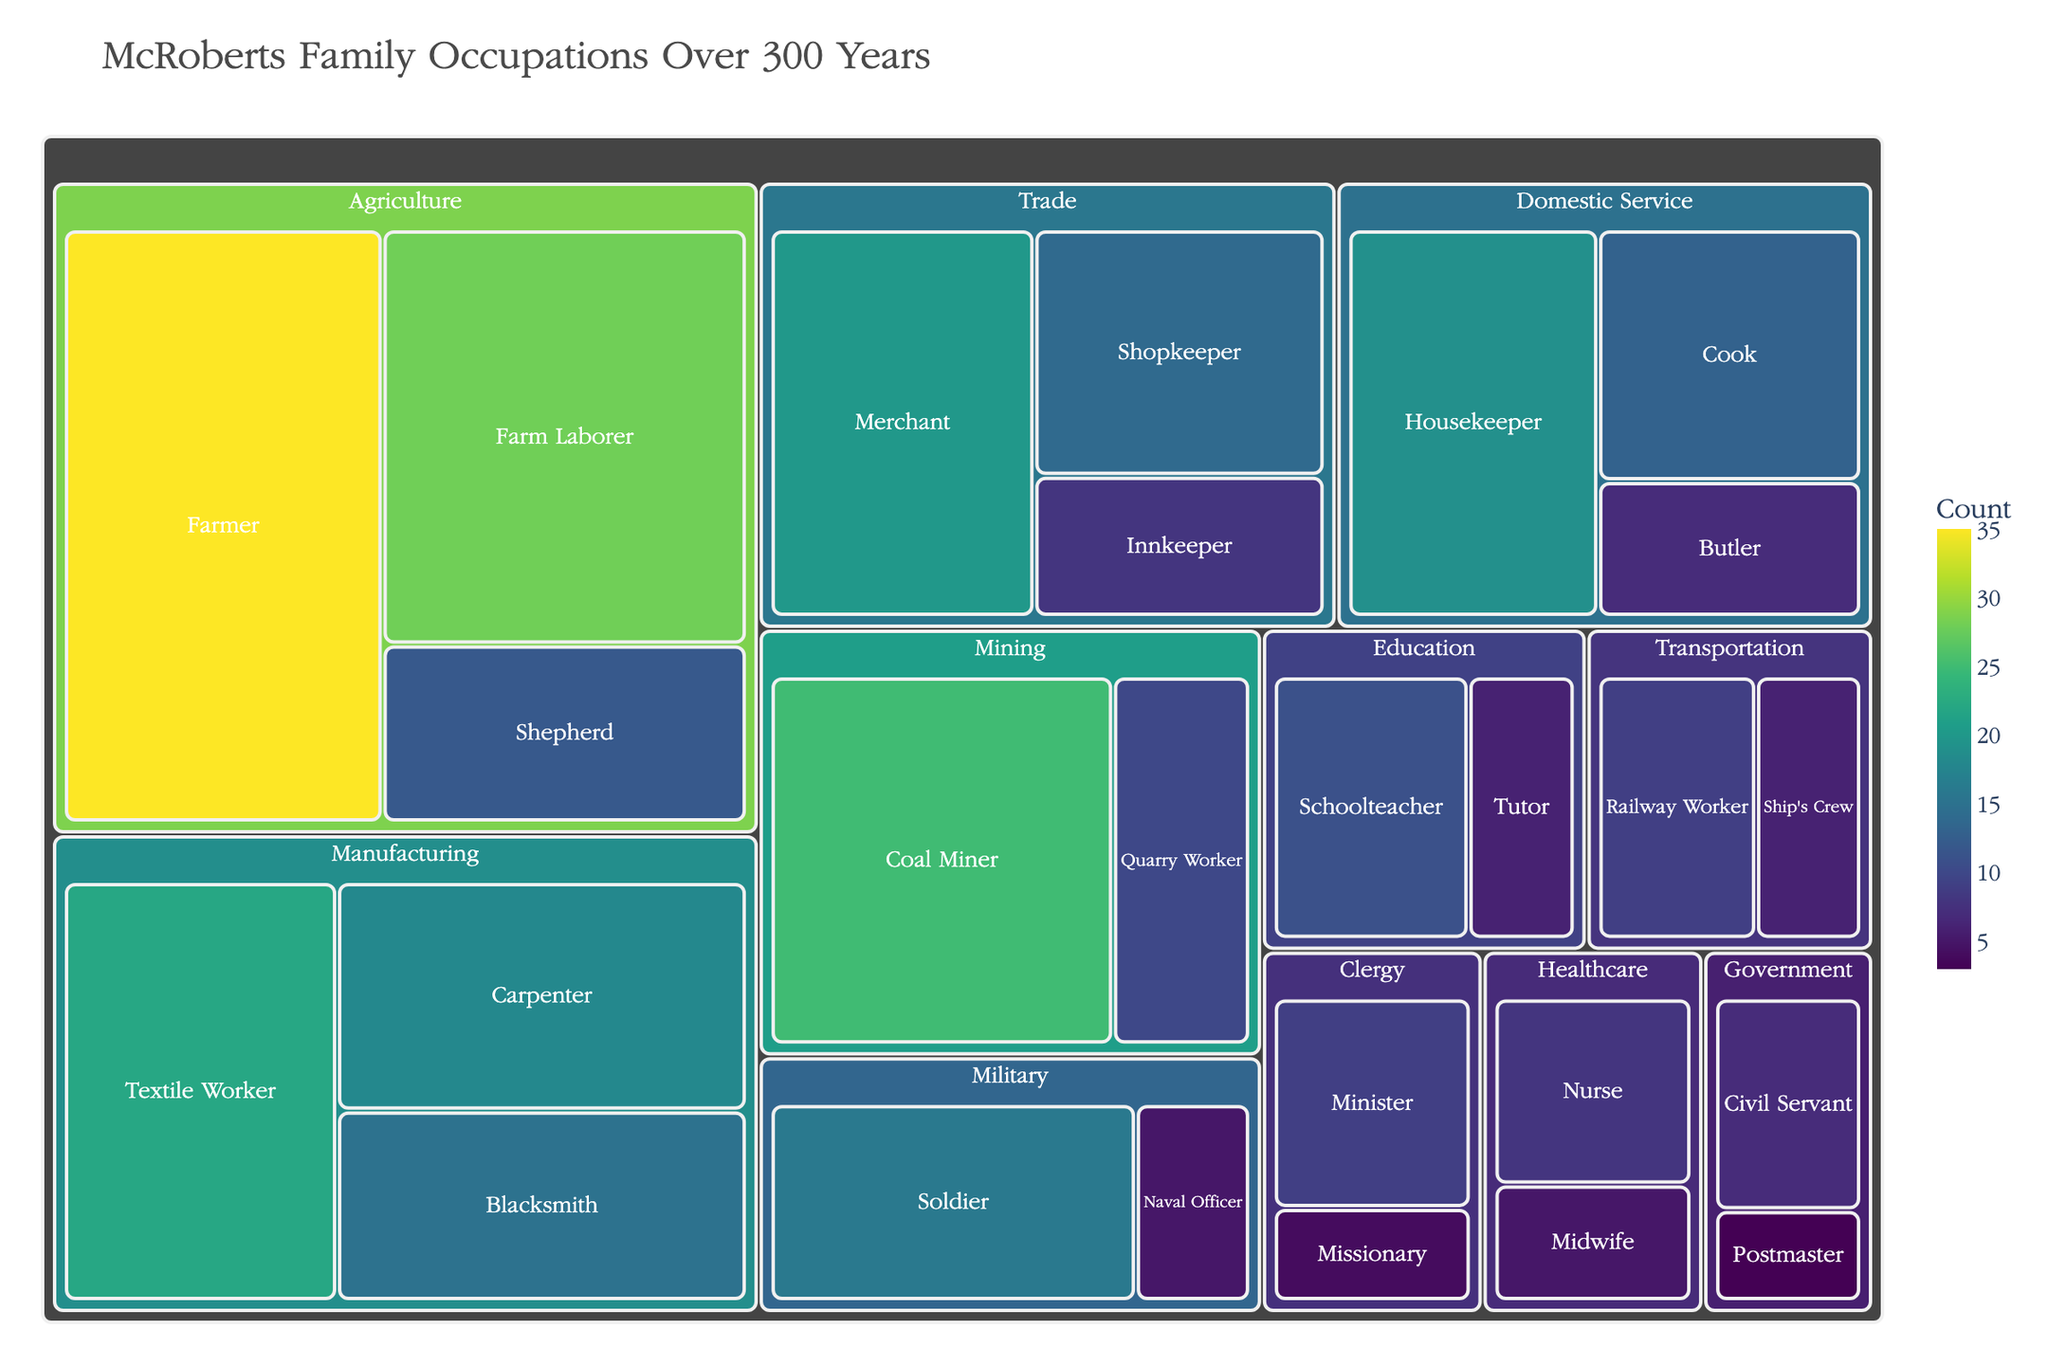What is the title of the treemap? The title is usually located at the top of the treemap and is clearly marked. Here, it states "McRoberts Family Occupations Over 300 Years."
Answer: McRoberts Family Occupations Over 300 Years Which industry has the highest count of occupations? To find the highest count, look at the size of the blocks. The largest block represents the industry with the most occupations, which is Agriculture.
Answer: Agriculture How many McRoberts were Farmers? Locate the "Farmer" occupation under the Agriculture industry. The number shown indicates how many McRoberts were Farmers, which is 35.
Answer: 35 Which occupation within the Domestic Service industry has the lowest count? Within the Domestic Service industry, identify the smallest block. The smallest block is for Butlers.
Answer: Butler How does the number of Textile Workers compare to Blacksmiths in the Manufacturing industry? Find the blocks for Textile Workers and Blacksmiths within the Manufacturing industry. Compare their counts; Textile Workers (22) is greater than Blacksmiths (15).
Answer: Textile Workers > Blacksmiths What is the total count of occupations in the Clergy industry? Add the counts for Minister (9) and Missionary (4). The total is 9 + 4 = 13.
Answer: 13 Which industry has the smallest count of occupations, and what is it? By comparing the sizes of the blocks, the smallest industry block is found to be Transportation. Adding the counts for Railway Worker (9) and Ship's Crew (6) gives a total of 15.
Answer: Transportation, 15 How many more Soldiers are there compared to Naval Officers in the Military industry? Subtract the count of Naval Officers (5) from the count of Soldiers (16). The difference is 16 - 5 = 11.
Answer: 11 What is the combined count of occupations in Healthcare and Government? Add the counts of all occupations in both industries. Healthcare: Nurse (8) + Midwife (5), total 13. Government: Civil Servant (7) + Postmaster (3), total 10. Combined total is 13 + 10 = 23.
Answer: 23 Which industry has the most diversity of occupations? Look for the industry with the most different types of occupations. Agriculture has three: Farmer, Farm Laborer, and Shepherd, the most among all industries.
Answer: Agriculture 